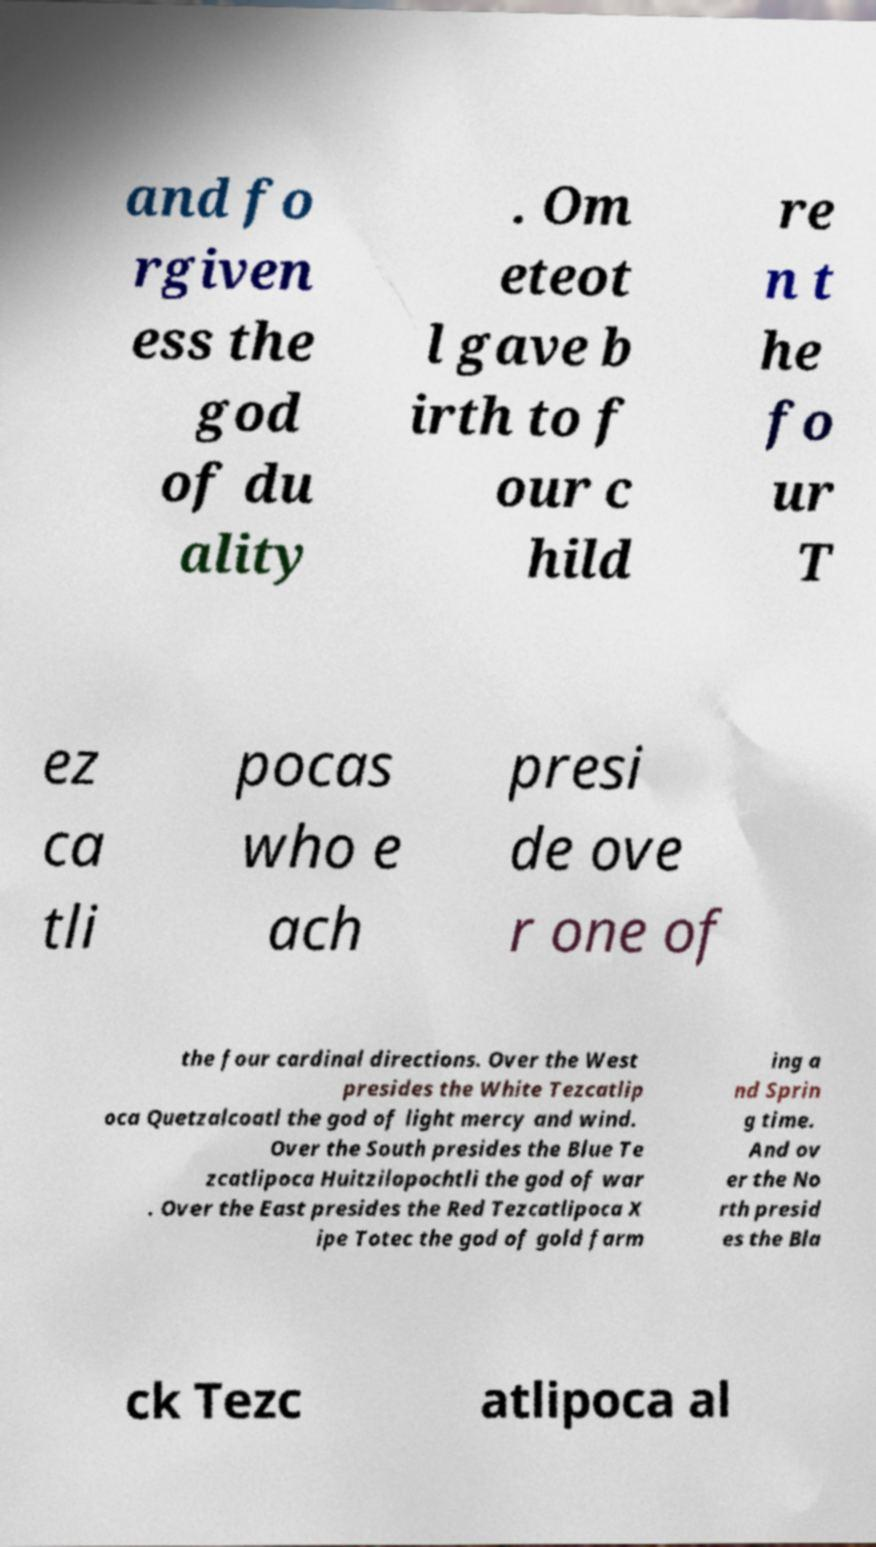Can you read and provide the text displayed in the image?This photo seems to have some interesting text. Can you extract and type it out for me? and fo rgiven ess the god of du ality . Om eteot l gave b irth to f our c hild re n t he fo ur T ez ca tli pocas who e ach presi de ove r one of the four cardinal directions. Over the West presides the White Tezcatlip oca Quetzalcoatl the god of light mercy and wind. Over the South presides the Blue Te zcatlipoca Huitzilopochtli the god of war . Over the East presides the Red Tezcatlipoca X ipe Totec the god of gold farm ing a nd Sprin g time. And ov er the No rth presid es the Bla ck Tezc atlipoca al 